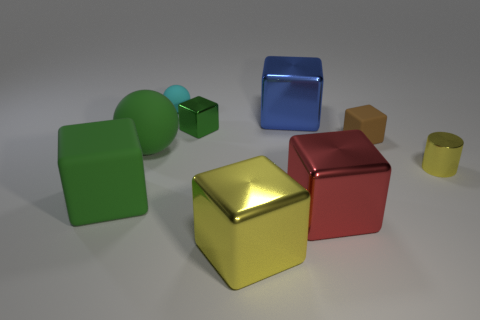Are any tiny brown metal spheres visible?
Offer a terse response. No. There is a yellow metal cube; does it have the same size as the matte ball behind the large blue metallic object?
Offer a terse response. No. Is there a cube in front of the green block to the left of the green sphere?
Your answer should be very brief. Yes. What is the material of the small thing that is left of the large red shiny thing and in front of the tiny sphere?
Make the answer very short. Metal. The metal block that is on the left side of the yellow metallic thing in front of the matte block to the left of the big yellow thing is what color?
Your response must be concise. Green. What color is the metallic object that is the same size as the metal cylinder?
Keep it short and to the point. Green. Does the small metal cylinder have the same color as the big shiny cube that is left of the blue thing?
Offer a terse response. Yes. There is a large green thing on the right side of the large block left of the small sphere; what is its material?
Your answer should be compact. Rubber. How many blocks are to the right of the big yellow thing and on the left side of the big yellow metal object?
Provide a short and direct response. 0. What number of other things are there of the same size as the brown object?
Your answer should be very brief. 3. 